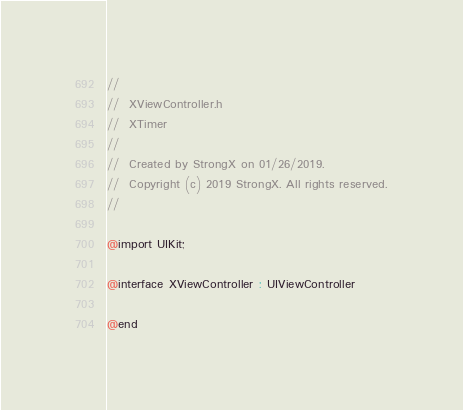Convert code to text. <code><loc_0><loc_0><loc_500><loc_500><_C_>//
//  XViewController.h
//  XTimer
//
//  Created by StrongX on 01/26/2019.
//  Copyright (c) 2019 StrongX. All rights reserved.
//

@import UIKit;

@interface XViewController : UIViewController

@end
</code> 